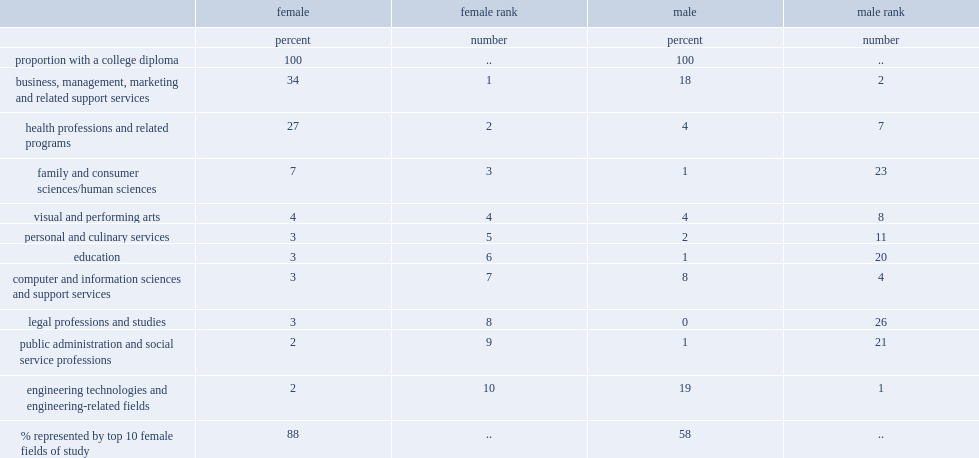What was the proportion of men with a college diploma in business, management, marketing and related support services in 2011? 18.0. What was the proportion of women with a college diploma in business, management, marketing and related support services in 2011? 34.0. What was the proportion of women aged 25 to 64 with a college diploma in health professions and related programs? 27.0. What was the proportion of women aged 25 to 64 with a college diploma in family and consumer sciences in 2011? 7.0. In 2011, women aged 25 to 64 were more likely to have college diploma in family and consumer sciences or health professions and related programs? Health professions and related programs. What was the ranking of engineering technologies and engineering related fields among men aged 25 to 64 in 2011? 1.0. What was the proportion of men aged 25 to 64 with a college diploma in engineering technologies and engineering related fields in 2011? 19.0. What was the proportion of women aged 25 to 64 with a college diploma in engineering technologies and engineering related fields in 2011? 2.0. What was the ranking of engineering technologies and engineering related fields among women aged 25 to 64 in 2011? 10.0. What was the proportion of women aged 25 to 64 had a college diploma in computer and information sciences and support services in 2011? 3.0. What was the ranking of computer and information sciences and support services among women aged 25 to 64 with a college diploma in 2011? 7.0. What was the proportion of men aged 25 to 64 had a college diploma in computer and information sciences and support services in 2011? 8.0. What was the ranking of computer and information sciences and support services among men aged 25 to 64 with a college diploma in 2011? 4.0. 